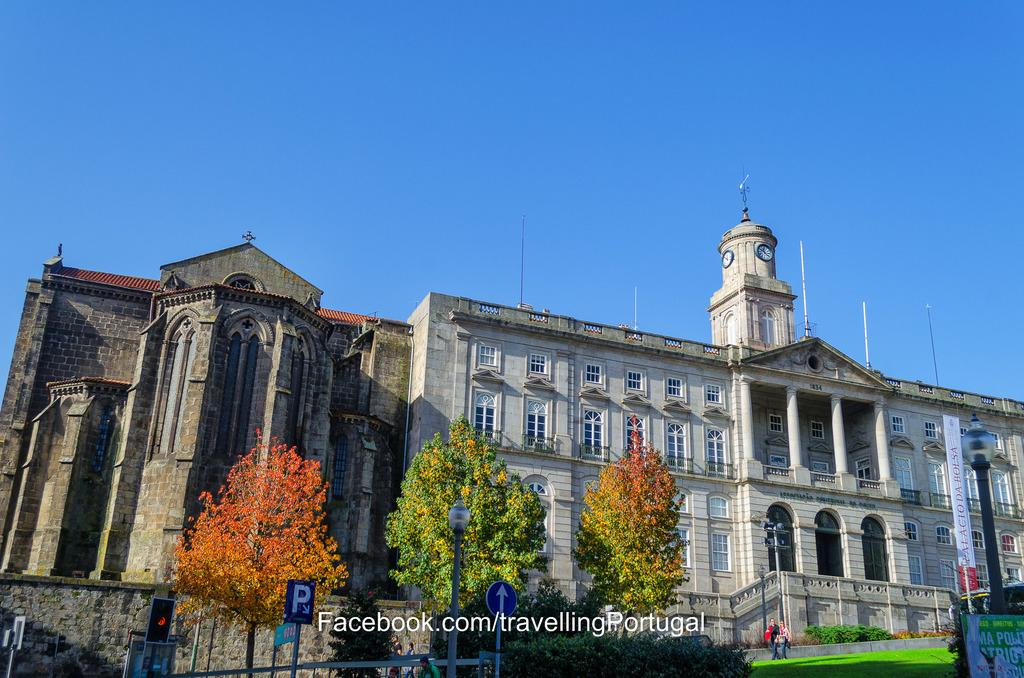<image>
Render a clear and concise summary of the photo. Large building on a sunny day with a Facebook link in the front. 